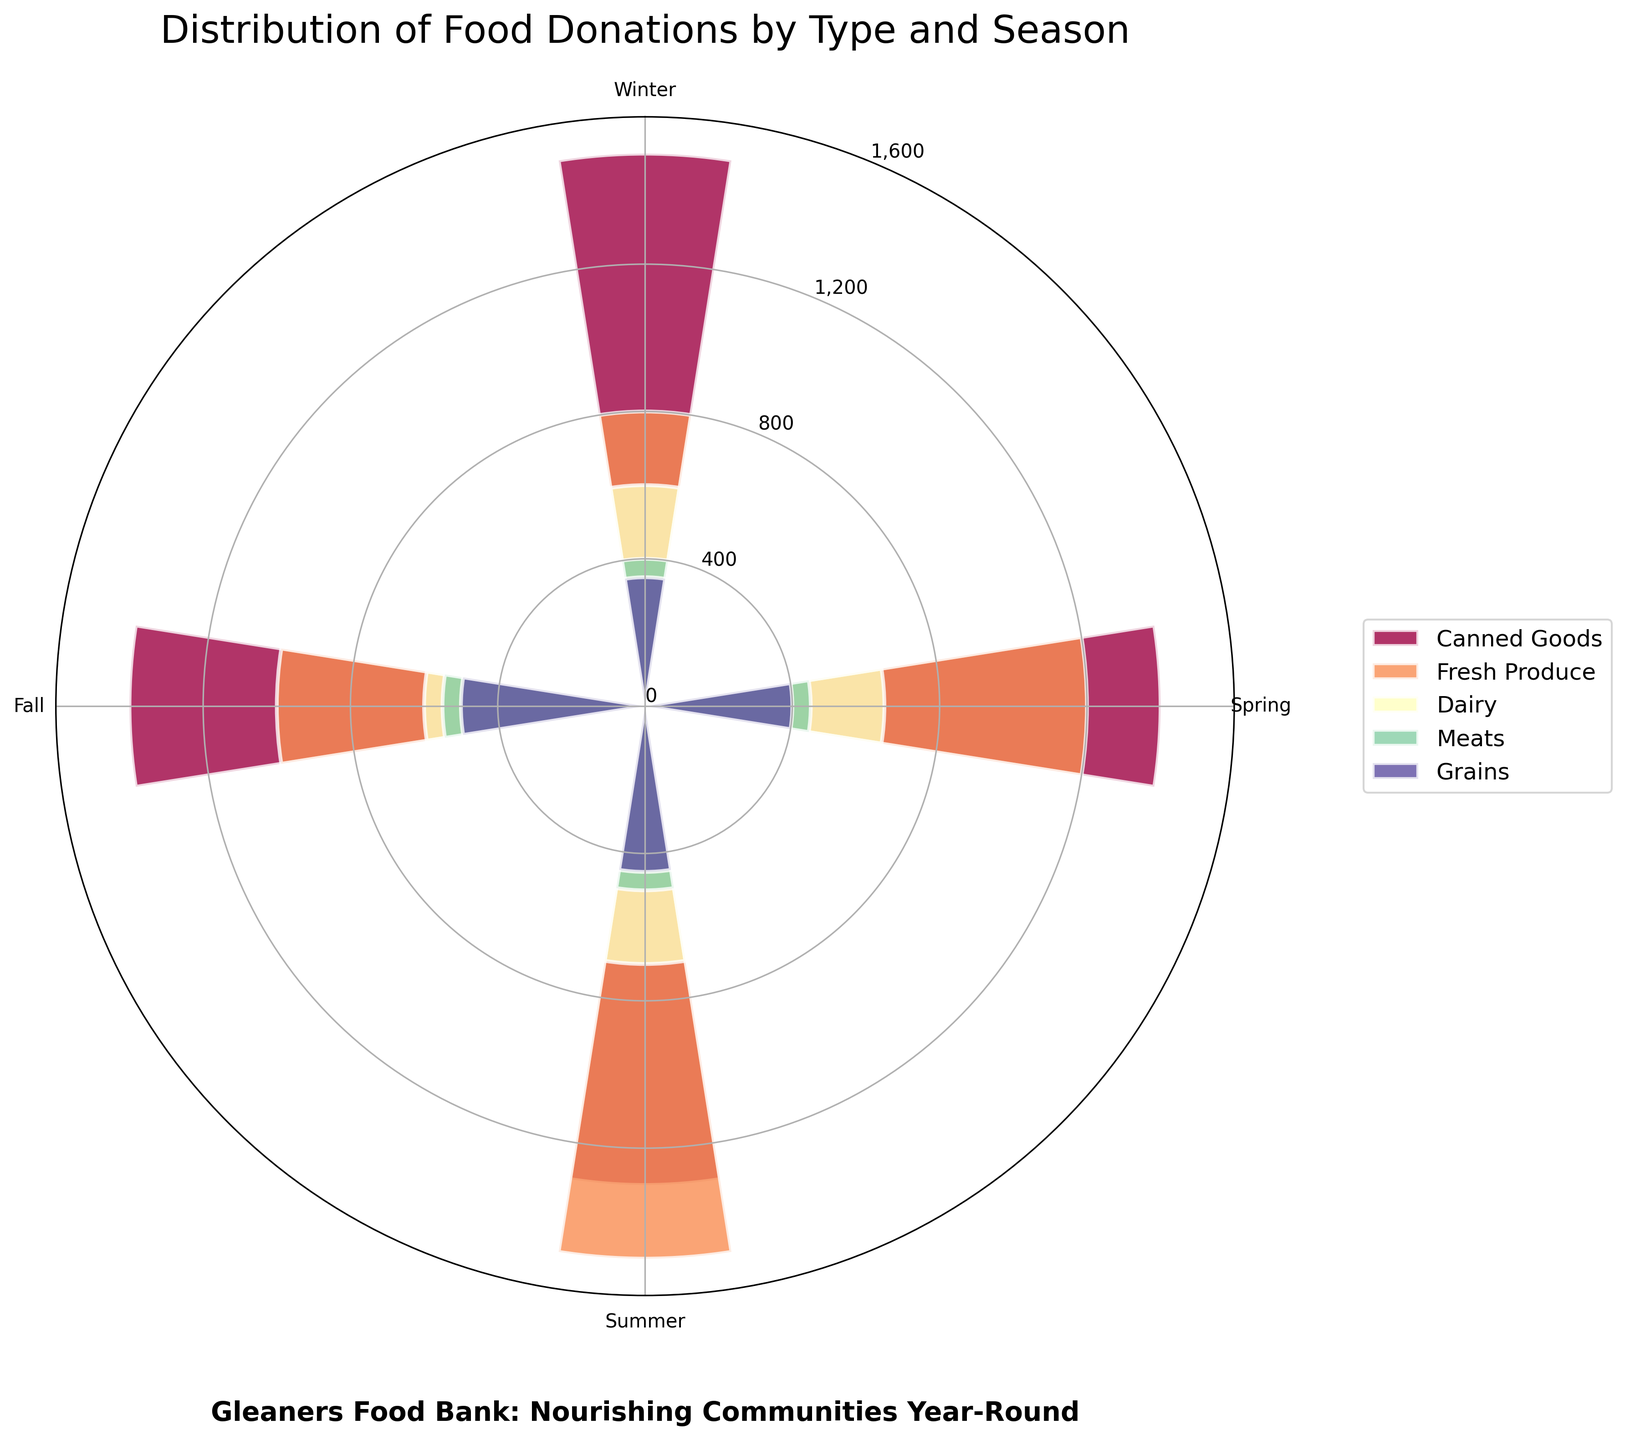What is the title of the rose chart? The title can be found at the top of the chart. It reads "Distribution of Food Donations by Type and Season."
Answer: Distribution of Food Donations by Type and Season How many food types are represented in the chart? By looking at the legend or the different colored sections in the chart, we can see there are 5 food types: Canned Goods, Fresh Produce, Dairy, Meats, and Grains.
Answer: 5 Which season has the highest donation of Fresh Produce? Find the Fresh Produce section for each season and identify which one has the largest length. Summer has the highest donation for Fresh Produce.
Answer: Summer What is the combined quantity of dairy donations over all seasons? Look at each season and add the dairy donation quantities: 600 (Winter) + 650 (Spring) + 700 (Summer) + 600 (Fall) = 2550
Answer: 2550 Which season has the least amount of total food donations? Calculate the total donations for each season: 
Winter = 1500 + 800 + 600 + 400 + 350 = 3650; 
Spring = 1400 + 1200 + 650 + 450 + 400 = 4100; 
Summer = 1300 + 1500 + 700 + 500 + 450 = 4450; 
Fall = 1400 + 1000 + 600 + 550 + 500 = 4050. 
Winter has the least donations at 3650.
Answer: Winter Compare the donations of meats between Spring and Fall. Which is higher? Check the lengths or values for the Meats section in both seasons. Spring has 450 and Fall has 550, so Fall is higher.
Answer: Fall Which two food types have the most similar donation quantities in Winter? Compare the lengths/quantities in Winter: 
Canned Goods (1500), Fresh Produce (800), Dairy (600), Meats (400), Grains (350). 
Meats and Grains are closest in quantity (400 and 350 respectively).
Answer: Meats and Grains What percentage of total summer donations is accounted for by Grains? Calculate the percentage: 
Total summer donations = 4450, Grains = 450. 
Percentage = (450 / 4450) * 100 = ~10.11%.
Answer: ~10.11% Which food type had the highest overall increase from Winter to Summer? Calculate the differences for each food type from Winter to Summer: 
Canned Goods: 1300 - 1500 = -200; 
Fresh Produce: 1500 - 800 = 700; 
Dairy: 700 - 600 = 100; 
Meats: 500 - 400 = 100; 
Grains: 450 - 350 = 100. 
Fresh Produce had the highest increase of 700.
Answer: Fresh Produce 